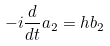<formula> <loc_0><loc_0><loc_500><loc_500>- i \frac { d } { d t } a _ { 2 } = h b _ { 2 }</formula> 